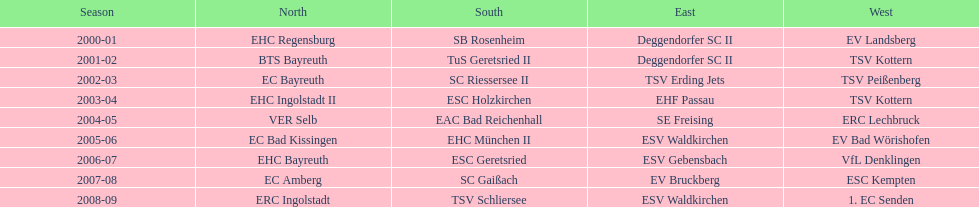What is the frequency of deggendorfer sc ii appearing on the list? 2. 